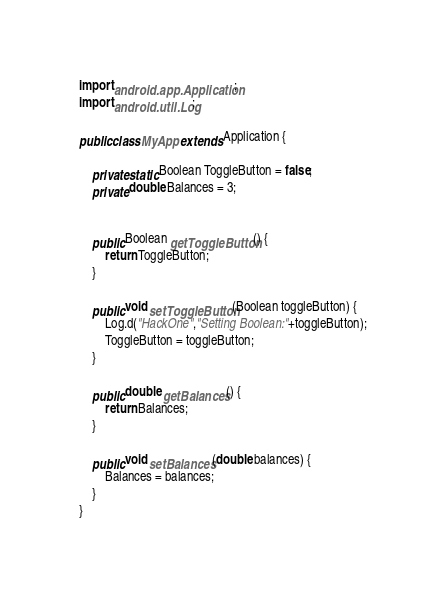Convert code to text. <code><loc_0><loc_0><loc_500><loc_500><_Java_>
import android.app.Application;
import android.util.Log;

public class MyApp extends Application {

	private static Boolean ToggleButton = false;
	private double Balances = 3;


	public Boolean getToggleButton() {
		return ToggleButton;
	}

	public void setToggleButton(Boolean toggleButton) {
		Log.d("HackOne","Setting Boolean:"+toggleButton);
		ToggleButton = toggleButton;
	}

	public double getBalances() {
		return Balances;
	}

	public void setBalances(double balances) {
		Balances = balances;
	}
}
</code> 